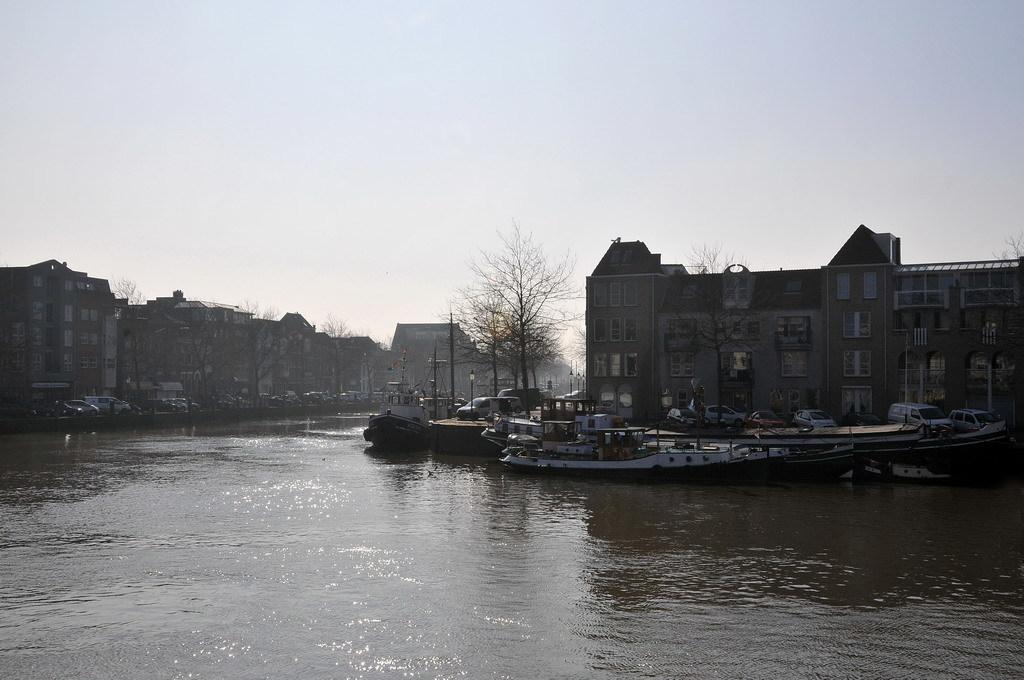What is happening in the water in the image? There are boats sailing on the water in the image. What type of structures can be seen in the image? There are buildings visible in the image. What type of vegetation is present in the image? Trees are present in the image. What are the poles used for in the image? The purpose of the poles is not specified, but they are visible in the image. What type of transportation is present in the image? Vehicles are present in the image. What part of the natural environment is visible in the image? The ground and the sky are visible in the image. How many wrens are sitting on the fire in the image? There are no wrens or fire present in the image. What type of baby animals can be seen playing with the vehicles in the image? There are no baby animals present in the image. 